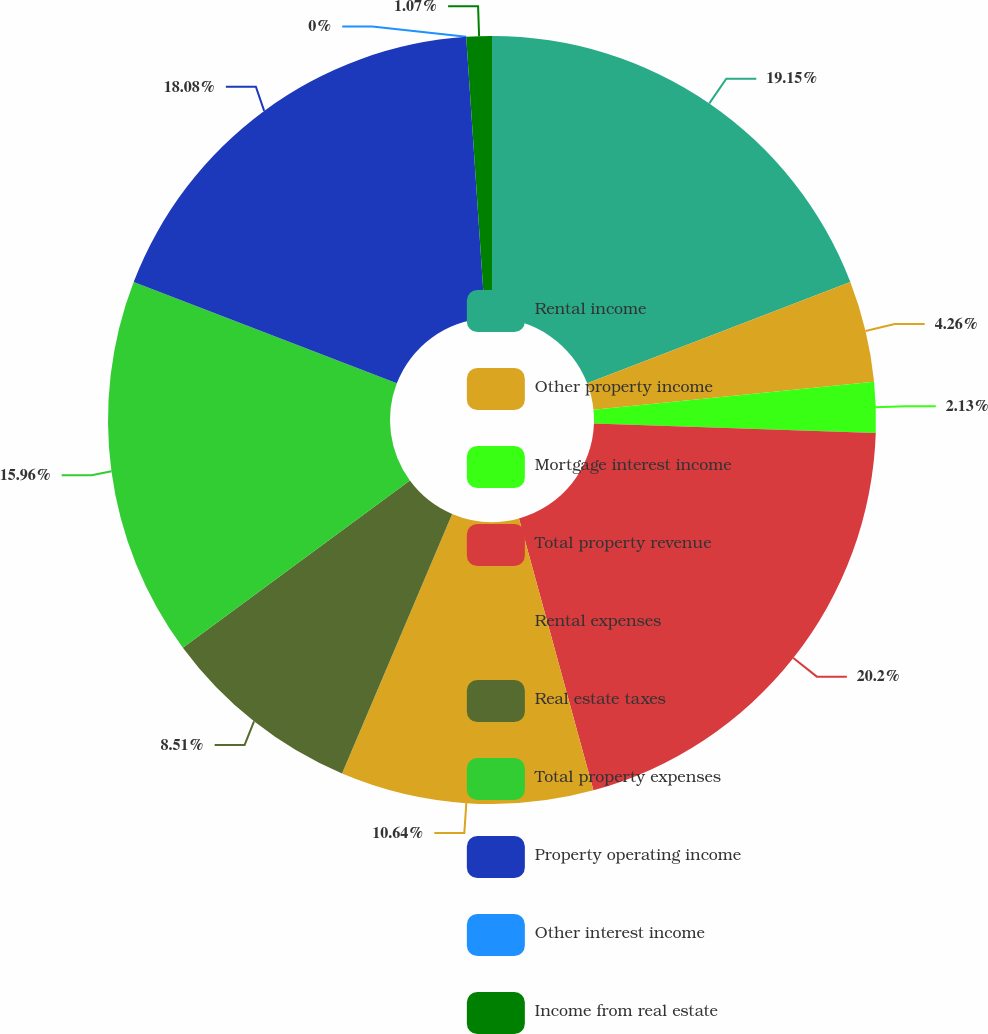<chart> <loc_0><loc_0><loc_500><loc_500><pie_chart><fcel>Rental income<fcel>Other property income<fcel>Mortgage interest income<fcel>Total property revenue<fcel>Rental expenses<fcel>Real estate taxes<fcel>Total property expenses<fcel>Property operating income<fcel>Other interest income<fcel>Income from real estate<nl><fcel>19.15%<fcel>4.26%<fcel>2.13%<fcel>20.21%<fcel>10.64%<fcel>8.51%<fcel>15.96%<fcel>18.08%<fcel>0.0%<fcel>1.07%<nl></chart> 